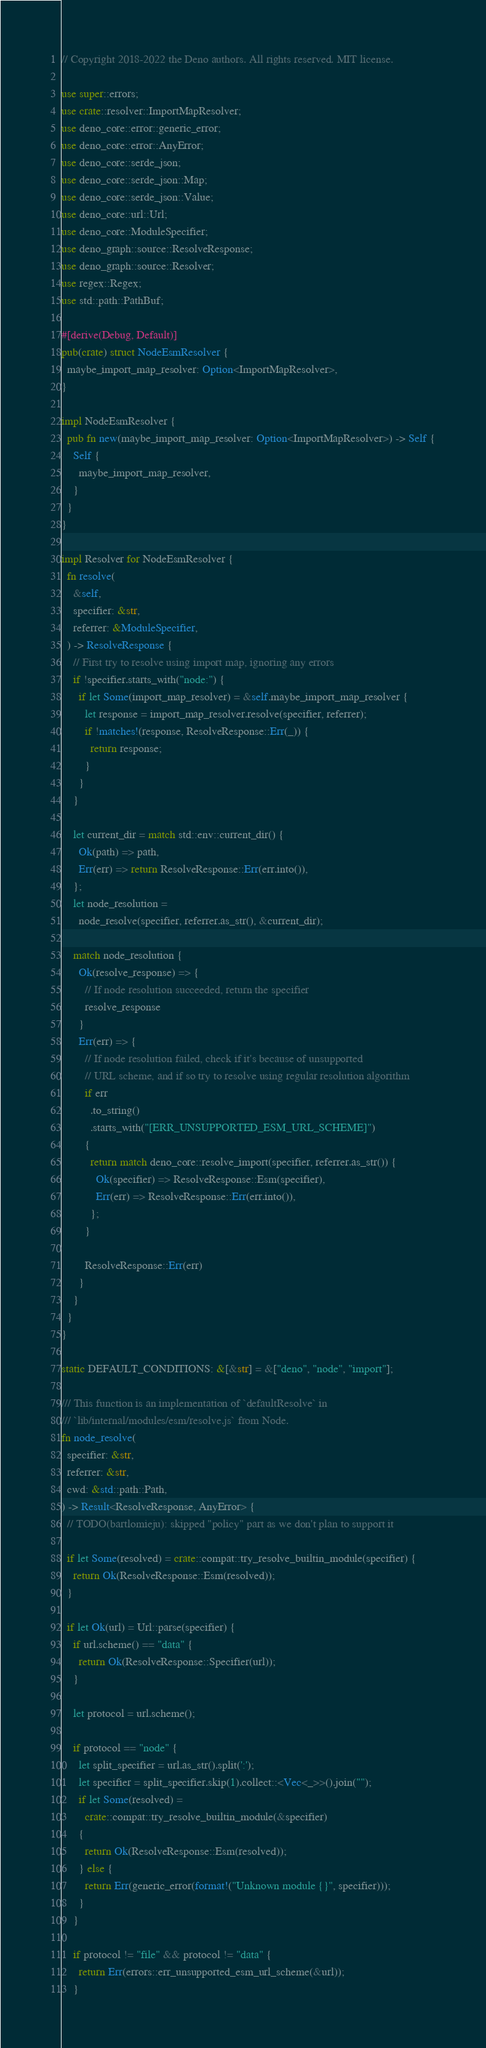<code> <loc_0><loc_0><loc_500><loc_500><_Rust_>// Copyright 2018-2022 the Deno authors. All rights reserved. MIT license.

use super::errors;
use crate::resolver::ImportMapResolver;
use deno_core::error::generic_error;
use deno_core::error::AnyError;
use deno_core::serde_json;
use deno_core::serde_json::Map;
use deno_core::serde_json::Value;
use deno_core::url::Url;
use deno_core::ModuleSpecifier;
use deno_graph::source::ResolveResponse;
use deno_graph::source::Resolver;
use regex::Regex;
use std::path::PathBuf;

#[derive(Debug, Default)]
pub(crate) struct NodeEsmResolver {
  maybe_import_map_resolver: Option<ImportMapResolver>,
}

impl NodeEsmResolver {
  pub fn new(maybe_import_map_resolver: Option<ImportMapResolver>) -> Self {
    Self {
      maybe_import_map_resolver,
    }
  }
}

impl Resolver for NodeEsmResolver {
  fn resolve(
    &self,
    specifier: &str,
    referrer: &ModuleSpecifier,
  ) -> ResolveResponse {
    // First try to resolve using import map, ignoring any errors
    if !specifier.starts_with("node:") {
      if let Some(import_map_resolver) = &self.maybe_import_map_resolver {
        let response = import_map_resolver.resolve(specifier, referrer);
        if !matches!(response, ResolveResponse::Err(_)) {
          return response;
        }
      }
    }

    let current_dir = match std::env::current_dir() {
      Ok(path) => path,
      Err(err) => return ResolveResponse::Err(err.into()),
    };
    let node_resolution =
      node_resolve(specifier, referrer.as_str(), &current_dir);

    match node_resolution {
      Ok(resolve_response) => {
        // If node resolution succeeded, return the specifier
        resolve_response
      }
      Err(err) => {
        // If node resolution failed, check if it's because of unsupported
        // URL scheme, and if so try to resolve using regular resolution algorithm
        if err
          .to_string()
          .starts_with("[ERR_UNSUPPORTED_ESM_URL_SCHEME]")
        {
          return match deno_core::resolve_import(specifier, referrer.as_str()) {
            Ok(specifier) => ResolveResponse::Esm(specifier),
            Err(err) => ResolveResponse::Err(err.into()),
          };
        }

        ResolveResponse::Err(err)
      }
    }
  }
}

static DEFAULT_CONDITIONS: &[&str] = &["deno", "node", "import"];

/// This function is an implementation of `defaultResolve` in
/// `lib/internal/modules/esm/resolve.js` from Node.
fn node_resolve(
  specifier: &str,
  referrer: &str,
  cwd: &std::path::Path,
) -> Result<ResolveResponse, AnyError> {
  // TODO(bartlomieju): skipped "policy" part as we don't plan to support it

  if let Some(resolved) = crate::compat::try_resolve_builtin_module(specifier) {
    return Ok(ResolveResponse::Esm(resolved));
  }

  if let Ok(url) = Url::parse(specifier) {
    if url.scheme() == "data" {
      return Ok(ResolveResponse::Specifier(url));
    }

    let protocol = url.scheme();

    if protocol == "node" {
      let split_specifier = url.as_str().split(':');
      let specifier = split_specifier.skip(1).collect::<Vec<_>>().join("");
      if let Some(resolved) =
        crate::compat::try_resolve_builtin_module(&specifier)
      {
        return Ok(ResolveResponse::Esm(resolved));
      } else {
        return Err(generic_error(format!("Unknown module {}", specifier)));
      }
    }

    if protocol != "file" && protocol != "data" {
      return Err(errors::err_unsupported_esm_url_scheme(&url));
    }
</code> 